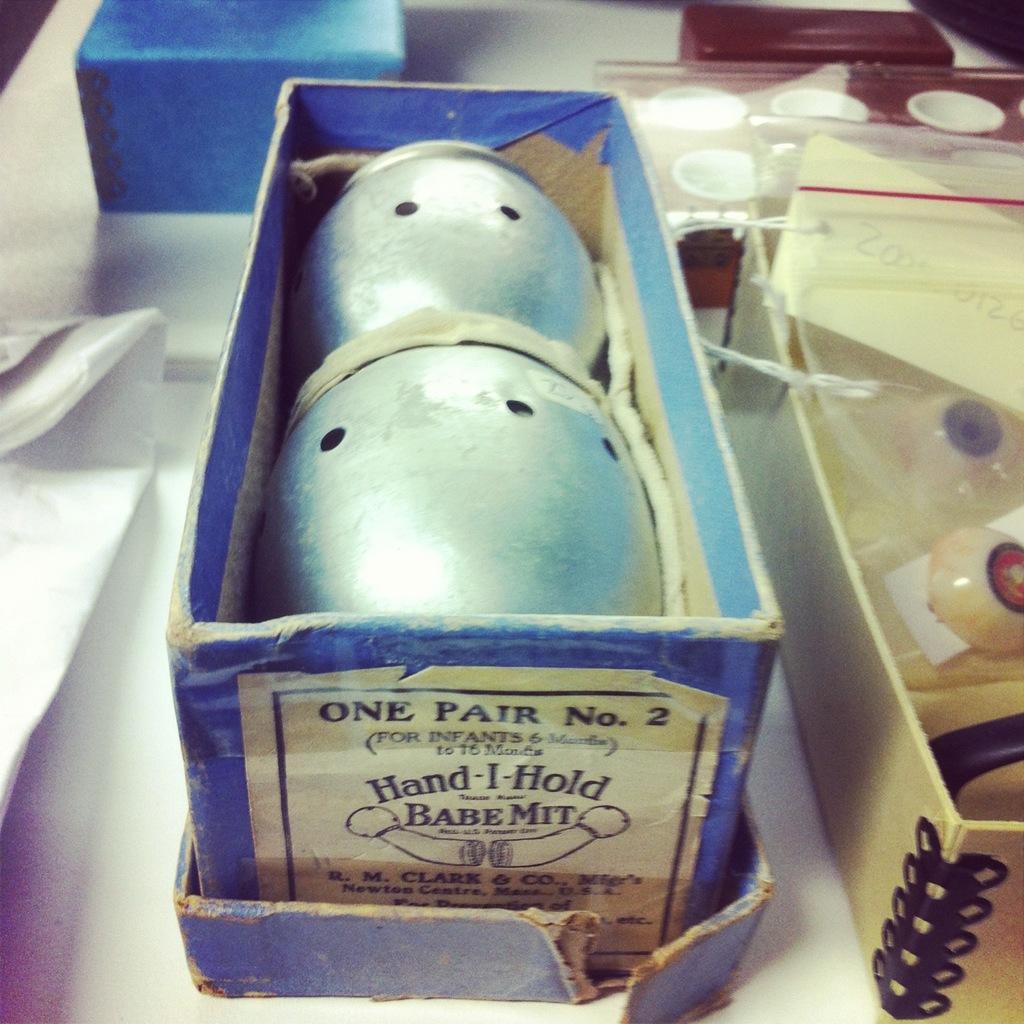How would you summarize this image in a sentence or two? There are boxes, this is an object. 